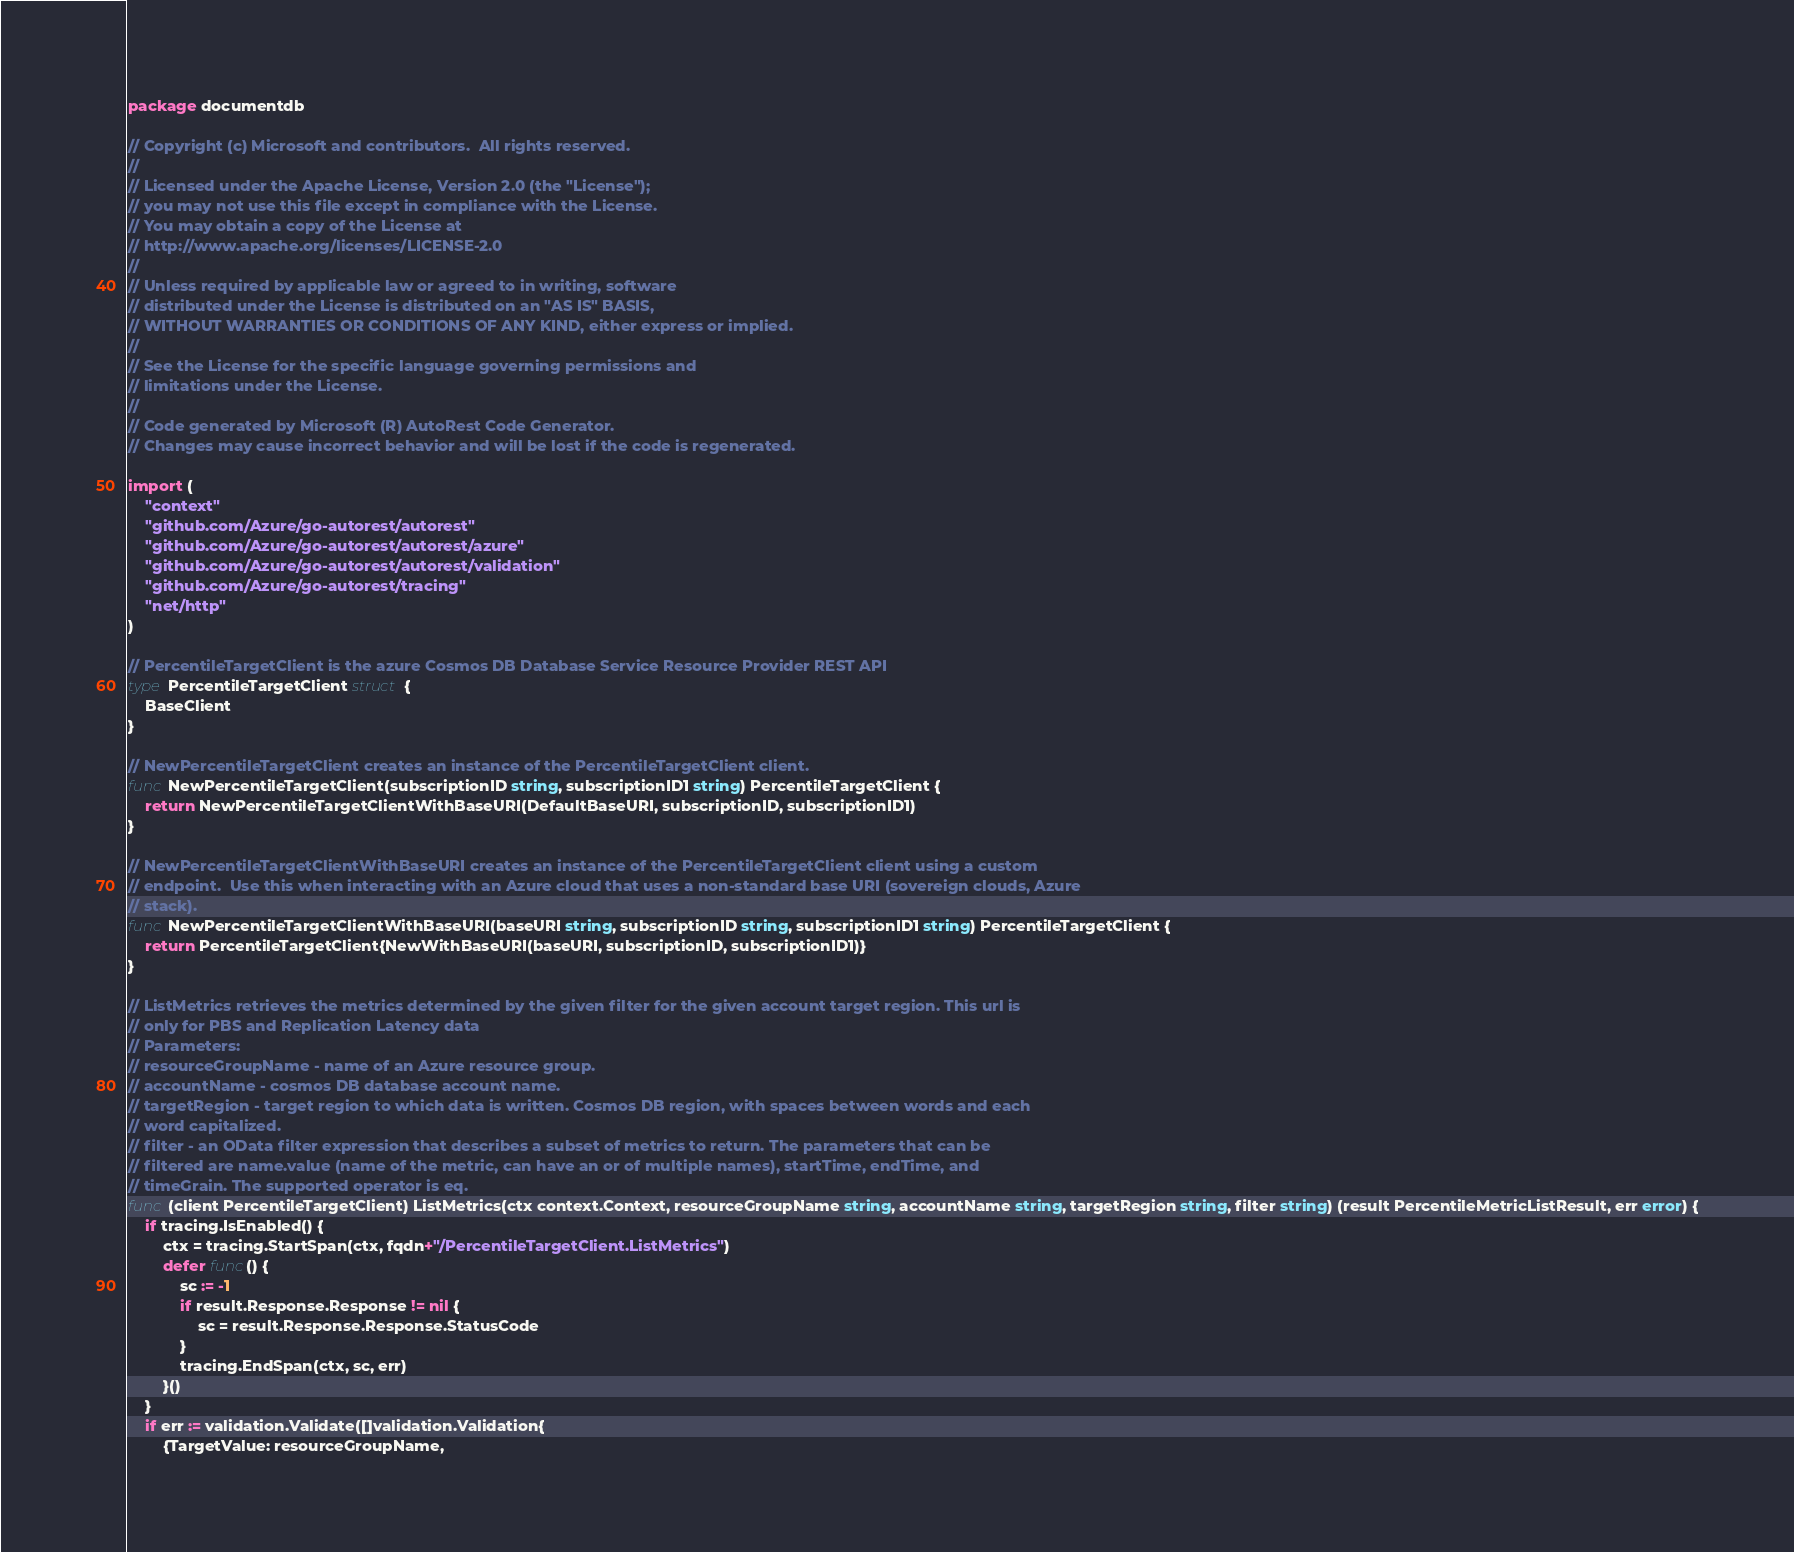<code> <loc_0><loc_0><loc_500><loc_500><_Go_>package documentdb

// Copyright (c) Microsoft and contributors.  All rights reserved.
//
// Licensed under the Apache License, Version 2.0 (the "License");
// you may not use this file except in compliance with the License.
// You may obtain a copy of the License at
// http://www.apache.org/licenses/LICENSE-2.0
//
// Unless required by applicable law or agreed to in writing, software
// distributed under the License is distributed on an "AS IS" BASIS,
// WITHOUT WARRANTIES OR CONDITIONS OF ANY KIND, either express or implied.
//
// See the License for the specific language governing permissions and
// limitations under the License.
//
// Code generated by Microsoft (R) AutoRest Code Generator.
// Changes may cause incorrect behavior and will be lost if the code is regenerated.

import (
	"context"
	"github.com/Azure/go-autorest/autorest"
	"github.com/Azure/go-autorest/autorest/azure"
	"github.com/Azure/go-autorest/autorest/validation"
	"github.com/Azure/go-autorest/tracing"
	"net/http"
)

// PercentileTargetClient is the azure Cosmos DB Database Service Resource Provider REST API
type PercentileTargetClient struct {
	BaseClient
}

// NewPercentileTargetClient creates an instance of the PercentileTargetClient client.
func NewPercentileTargetClient(subscriptionID string, subscriptionID1 string) PercentileTargetClient {
	return NewPercentileTargetClientWithBaseURI(DefaultBaseURI, subscriptionID, subscriptionID1)
}

// NewPercentileTargetClientWithBaseURI creates an instance of the PercentileTargetClient client using a custom
// endpoint.  Use this when interacting with an Azure cloud that uses a non-standard base URI (sovereign clouds, Azure
// stack).
func NewPercentileTargetClientWithBaseURI(baseURI string, subscriptionID string, subscriptionID1 string) PercentileTargetClient {
	return PercentileTargetClient{NewWithBaseURI(baseURI, subscriptionID, subscriptionID1)}
}

// ListMetrics retrieves the metrics determined by the given filter for the given account target region. This url is
// only for PBS and Replication Latency data
// Parameters:
// resourceGroupName - name of an Azure resource group.
// accountName - cosmos DB database account name.
// targetRegion - target region to which data is written. Cosmos DB region, with spaces between words and each
// word capitalized.
// filter - an OData filter expression that describes a subset of metrics to return. The parameters that can be
// filtered are name.value (name of the metric, can have an or of multiple names), startTime, endTime, and
// timeGrain. The supported operator is eq.
func (client PercentileTargetClient) ListMetrics(ctx context.Context, resourceGroupName string, accountName string, targetRegion string, filter string) (result PercentileMetricListResult, err error) {
	if tracing.IsEnabled() {
		ctx = tracing.StartSpan(ctx, fqdn+"/PercentileTargetClient.ListMetrics")
		defer func() {
			sc := -1
			if result.Response.Response != nil {
				sc = result.Response.Response.StatusCode
			}
			tracing.EndSpan(ctx, sc, err)
		}()
	}
	if err := validation.Validate([]validation.Validation{
		{TargetValue: resourceGroupName,</code> 